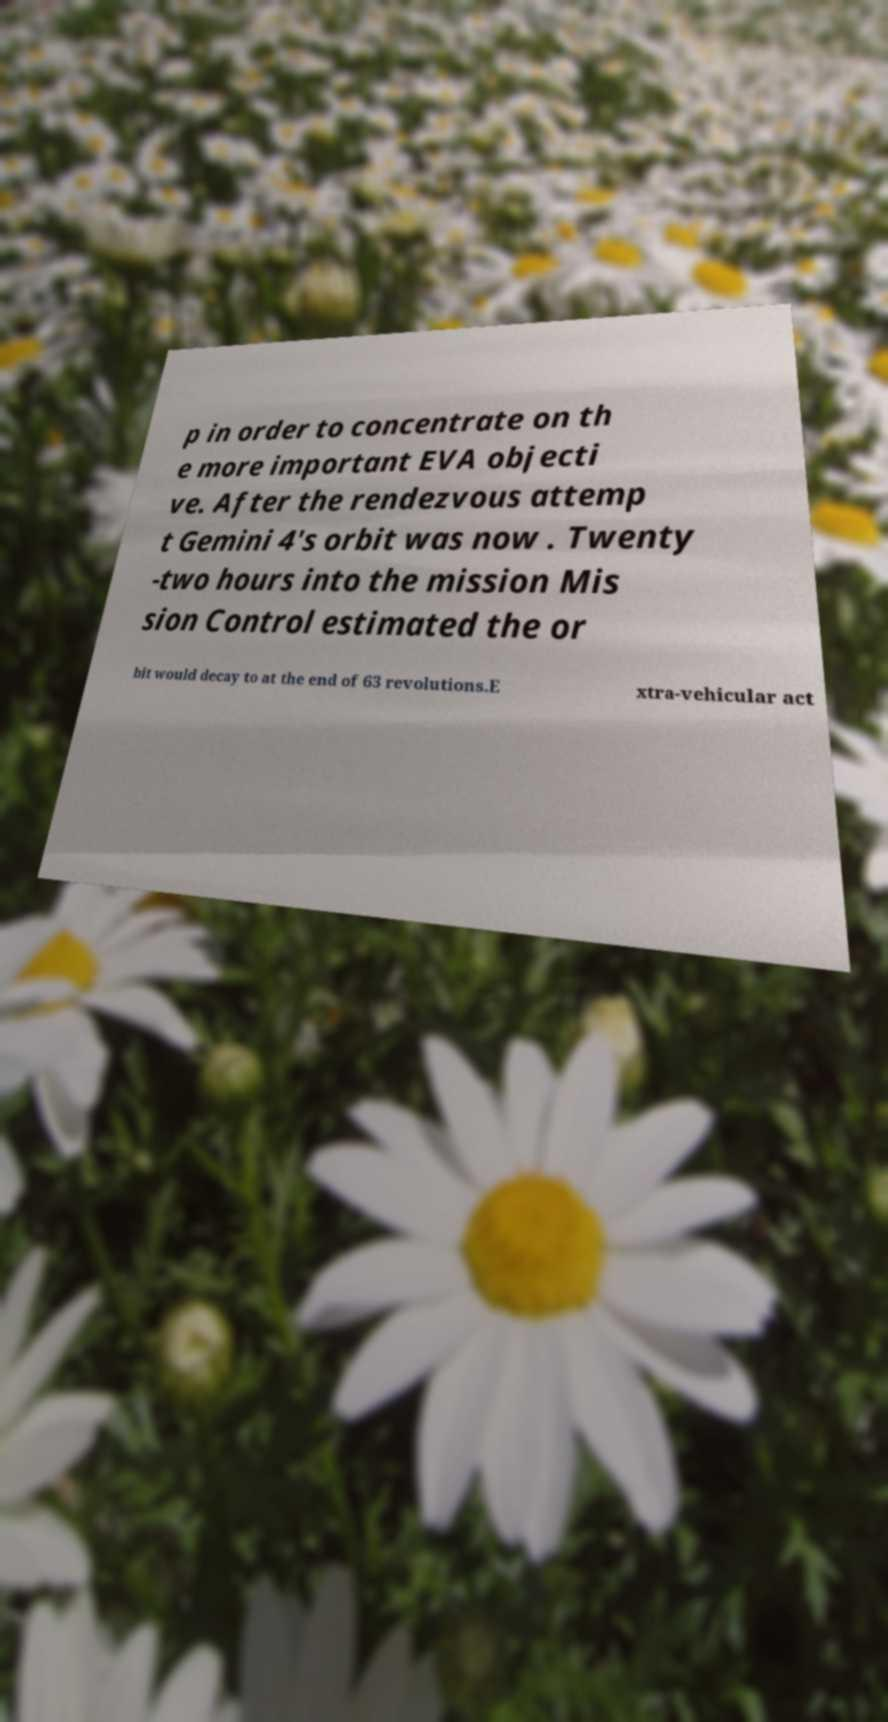There's text embedded in this image that I need extracted. Can you transcribe it verbatim? p in order to concentrate on th e more important EVA objecti ve. After the rendezvous attemp t Gemini 4's orbit was now . Twenty -two hours into the mission Mis sion Control estimated the or bit would decay to at the end of 63 revolutions.E xtra-vehicular act 